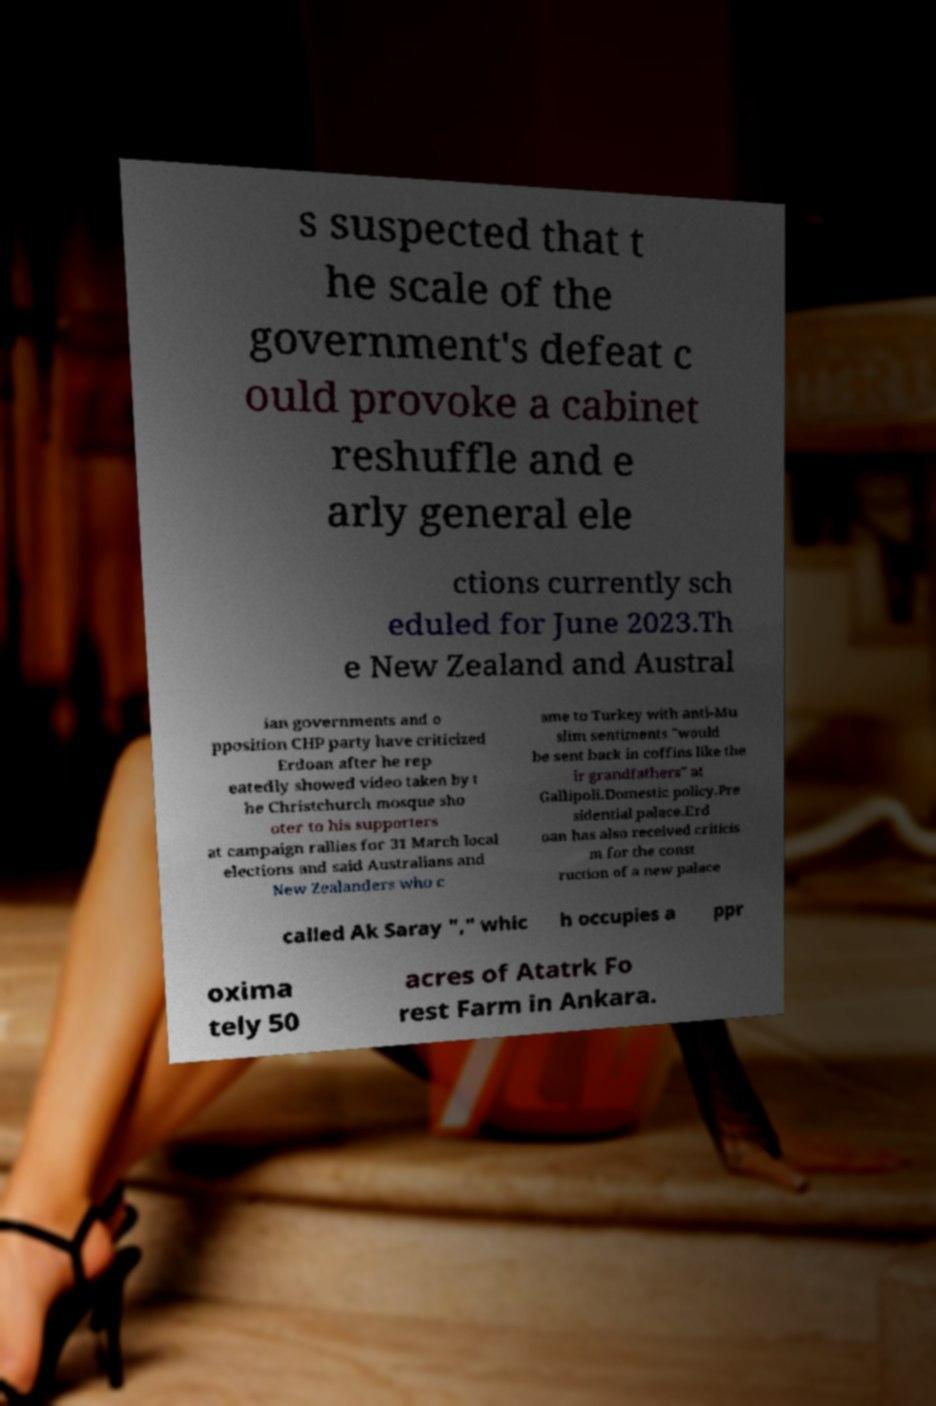Can you accurately transcribe the text from the provided image for me? s suspected that t he scale of the government's defeat c ould provoke a cabinet reshuffle and e arly general ele ctions currently sch eduled for June 2023.Th e New Zealand and Austral ian governments and o pposition CHP party have criticized Erdoan after he rep eatedly showed video taken by t he Christchurch mosque sho oter to his supporters at campaign rallies for 31 March local elections and said Australians and New Zealanders who c ame to Turkey with anti-Mu slim sentiments "would be sent back in coffins like the ir grandfathers" at Gallipoli.Domestic policy.Pre sidential palace.Erd oan has also received criticis m for the const ruction of a new palace called Ak Saray "," whic h occupies a ppr oxima tely 50 acres of Atatrk Fo rest Farm in Ankara. 